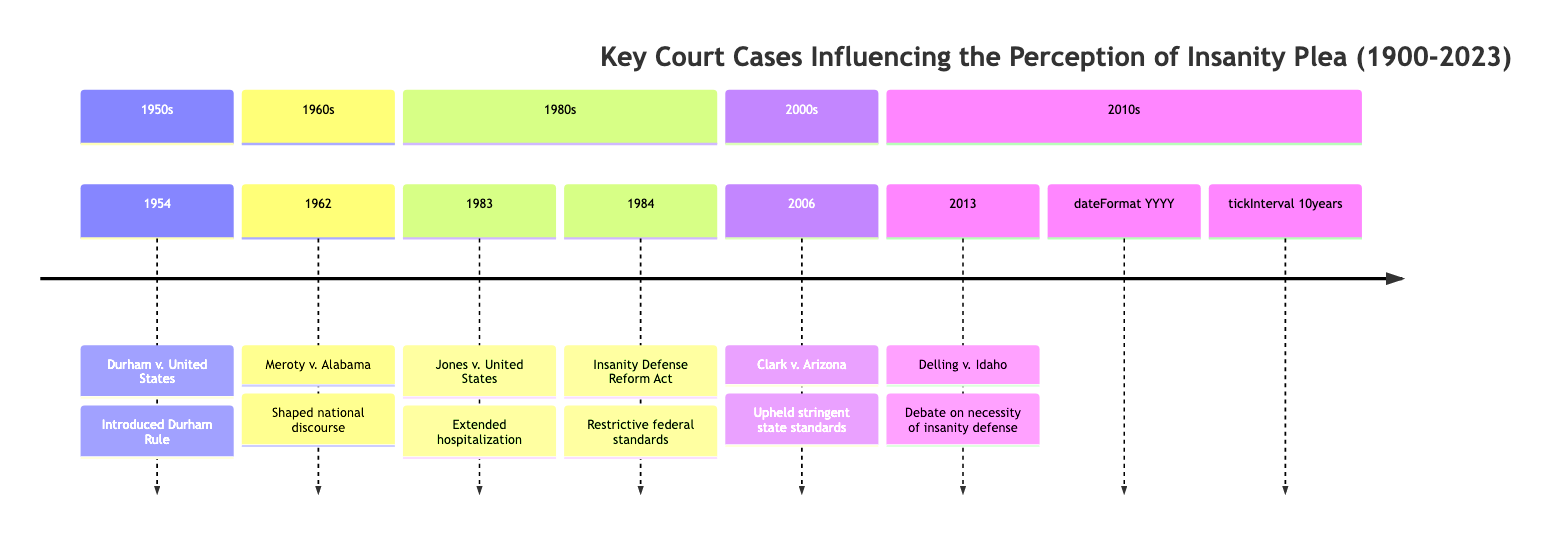What is the earliest case listed in the timeline? The timeline starts with the case "Durham v. United States," which occurred in 1954. This can be determined by looking at the years listed in the timeline and identifying the smallest year.
Answer: Durham v. United States How many court cases are listed in the timeline? By counting the entries in the timeline, there are a total of six cases presented from 1954 to 2013.
Answer: 6 What significant impact did the Insanity Defense Reform Act have? The Insanity Defense Reform Act, passed in 1984, made the federal standards for the insanity defense more restrictive, meaning that it tightened the criteria under which a defendant could claim an insanity plea. This impact is indicated in the description for that case in the timeline.
Answer: Restrictive federal standards Which case upheld Arizona’s standard for insanity? The case "Clark v. Arizona," which is listed in the timeline for the year 2006, specifically mentions the upholding of Arizona’s standard, including stringent tests for mental incapacity. This can be inferred by looking at the key impacts related to individual cases.
Answer: Clark v. Arizona Which case introduced the Durham Rule? The case that introduced the Durham Rule is "Durham v. United States," which is clearly stated in the timeline. This is evident as it is listed along with its corresponding impact in the timeline entry.
Answer: Durham v. United States Which case sparked a debate on the necessity of the insanity defense? The case "Delling v. Idaho," from 2013, led to significant discussions regarding the necessity and variation of the insanity defense across states, as indicated in the timeline. Therefore, this case is directly linked to that debate.
Answer: Delling v. Idaho What year did the Supreme Court decide on "Jones v. United States"? The decision for "Jones v. United States" was made in 1983. This year can be found by locating the specific case within the timeline and noting its corresponding year.
Answer: 1983 What impact did the case "Jones v. United States" have regarding hospitalization? The case confirmed that individuals acquitted by reason of insanity could face hospitalization longer than incarceration time had they been found guilty. This impact is a key element in the timeline entry for that case.
Answer: Extended hospitalization Which case deals with the application of the Durham Rule in state courts? The case "Meroty v. Alabama," which occurred in 1962, specifically addresses the application of the Durham Rule within state courts, as mentioned in its description in the timeline.
Answer: Meroty v. Alabama 